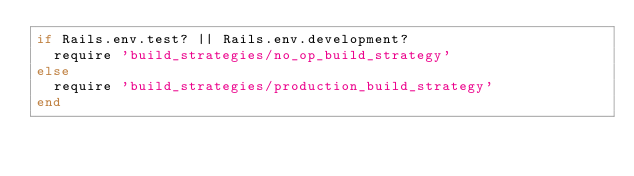<code> <loc_0><loc_0><loc_500><loc_500><_Ruby_>if Rails.env.test? || Rails.env.development?
  require 'build_strategies/no_op_build_strategy'
else
  require 'build_strategies/production_build_strategy'
end
</code> 